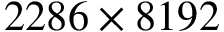<formula> <loc_0><loc_0><loc_500><loc_500>2 2 8 6 \times 8 1 9 2</formula> 